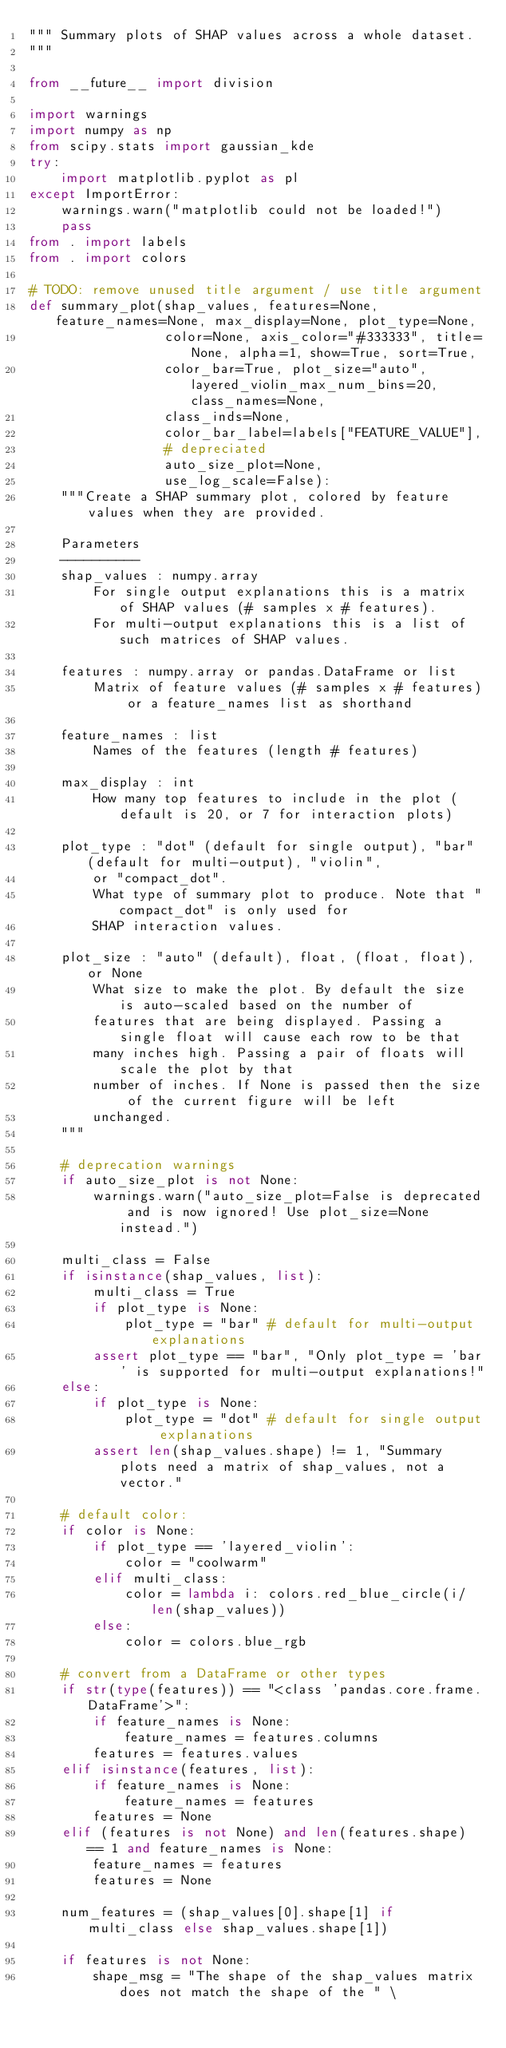Convert code to text. <code><loc_0><loc_0><loc_500><loc_500><_Python_>""" Summary plots of SHAP values across a whole dataset.
"""

from __future__ import division

import warnings
import numpy as np
from scipy.stats import gaussian_kde
try:
    import matplotlib.pyplot as pl
except ImportError:
    warnings.warn("matplotlib could not be loaded!")
    pass
from . import labels
from . import colors

# TODO: remove unused title argument / use title argument
def summary_plot(shap_values, features=None, feature_names=None, max_display=None, plot_type=None,
                 color=None, axis_color="#333333", title=None, alpha=1, show=True, sort=True,
                 color_bar=True, plot_size="auto", layered_violin_max_num_bins=20, class_names=None,
                 class_inds=None,
                 color_bar_label=labels["FEATURE_VALUE"],
                 # depreciated
                 auto_size_plot=None,
                 use_log_scale=False):
    """Create a SHAP summary plot, colored by feature values when they are provided.

    Parameters
    ----------
    shap_values : numpy.array
        For single output explanations this is a matrix of SHAP values (# samples x # features).
        For multi-output explanations this is a list of such matrices of SHAP values.

    features : numpy.array or pandas.DataFrame or list
        Matrix of feature values (# samples x # features) or a feature_names list as shorthand

    feature_names : list
        Names of the features (length # features)

    max_display : int
        How many top features to include in the plot (default is 20, or 7 for interaction plots)

    plot_type : "dot" (default for single output), "bar" (default for multi-output), "violin",
        or "compact_dot".
        What type of summary plot to produce. Note that "compact_dot" is only used for
        SHAP interaction values.

    plot_size : "auto" (default), float, (float, float), or None
        What size to make the plot. By default the size is auto-scaled based on the number of
        features that are being displayed. Passing a single float will cause each row to be that 
        many inches high. Passing a pair of floats will scale the plot by that
        number of inches. If None is passed then the size of the current figure will be left
        unchanged.
    """

    # deprecation warnings
    if auto_size_plot is not None:
        warnings.warn("auto_size_plot=False is deprecated and is now ignored! Use plot_size=None instead.")

    multi_class = False
    if isinstance(shap_values, list):
        multi_class = True
        if plot_type is None:
            plot_type = "bar" # default for multi-output explanations
        assert plot_type == "bar", "Only plot_type = 'bar' is supported for multi-output explanations!"
    else:
        if plot_type is None:
            plot_type = "dot" # default for single output explanations
        assert len(shap_values.shape) != 1, "Summary plots need a matrix of shap_values, not a vector."

    # default color:
    if color is None:
        if plot_type == 'layered_violin':
            color = "coolwarm"
        elif multi_class:
            color = lambda i: colors.red_blue_circle(i/len(shap_values))
        else:
            color = colors.blue_rgb

    # convert from a DataFrame or other types
    if str(type(features)) == "<class 'pandas.core.frame.DataFrame'>":
        if feature_names is None:
            feature_names = features.columns
        features = features.values
    elif isinstance(features, list):
        if feature_names is None:
            feature_names = features
        features = None
    elif (features is not None) and len(features.shape) == 1 and feature_names is None:
        feature_names = features
        features = None

    num_features = (shap_values[0].shape[1] if multi_class else shap_values.shape[1])

    if features is not None:
        shape_msg = "The shape of the shap_values matrix does not match the shape of the " \</code> 